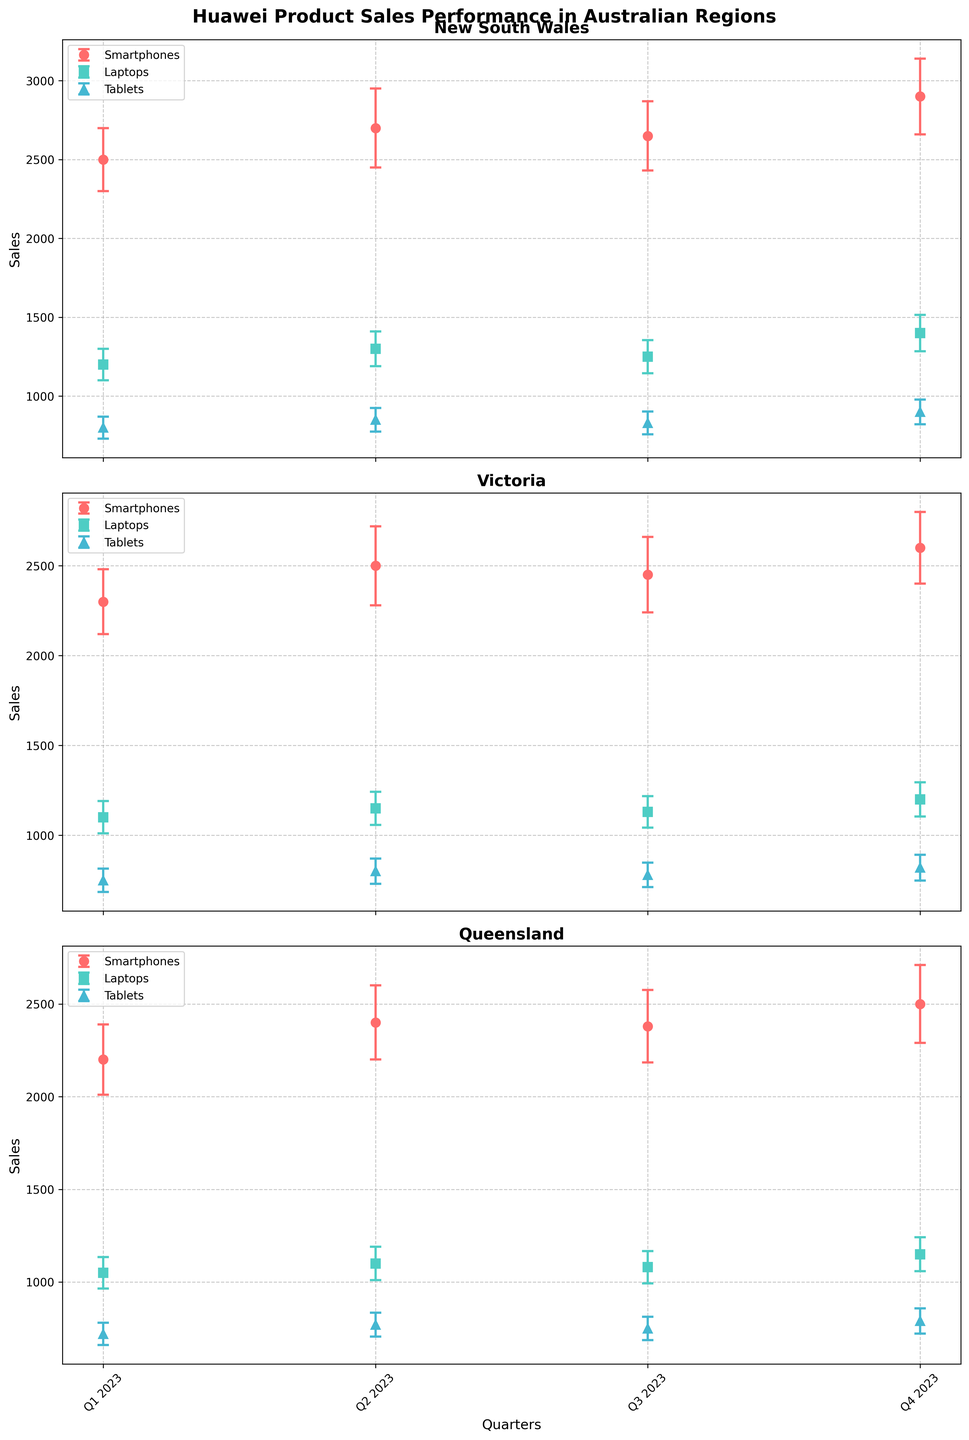What is the overall title of the figure? The overall title of the figure is displayed at the top and reads "Huawei Product Sales Performance in Australian Regions." One can directly see this from the figure's header.
Answer: Huawei Product Sales Performance in Australian Regions Which regions are represented in the subplots? The subplots are labeled according to the regions, which can be directly read from the titles of each subplot. These regions are "New South Wales," "Victoria," and "Queensland."
Answer: New South Wales, Victoria, Queensland How do the sales of Smartphones in New South Wales change from Q1 to Q4 2023? Reviewing the New South Wales subplot and the error bars for Smartphones, the sales figures in thousands are as follows: Q1: 2500, Q2: 2700, Q3: 2650, Q4: 2900. Thus, sales generally increase over the quarters.
Answer: They generally increase What is the highest variance in Tablet sales in Queensland? Looking at the error bars in the Queensland subplot for Tablets, the highest variance is in Q4 2023 at 68 units.
Answer: 68 Which product line has the least sales variance in Victoria throughout the year? Examining the error bars in the Victoria subplot across all product lines, Laptops exhibit the least variance throughout the quarters. This can be seen as the smallest error bars across all products.
Answer: Laptops Compare the average sales of Smartphones between New South Wales and Victoria. To find the average, sum the sales figures for each region and divide by four quarters. NSW: (2500 + 2700 + 2650 + 2900)/4 = 2687.5; Victoria: (2300 + 2500 + 2450 + 2600)/4 = 2462.5. NSW has higher average sales.
Answer: NSW: 2687.5, VIC: 2462.5 Which quarter shows the maximum sales for Laptops in New South Wales? In the New South Wales subplot, examining the data points for Laptops, Q4 2023 has the highest sales at 1400.
Answer: Q4 2023 Compare the trends of Tablet sales in Victoria and Queensland. Both subplots for Victoria and Queensland show the Tablet sales. In Victoria, there is a gradual increase from Q1 to Q4 2023. In Queensland, there is also an increase, but it's less pronounced.
Answer: Both increase; Victoria more pronounced Are there any quarters where the Laptop sales in New South Wales are equal to Laptop sales in Victoria? By examining both subplots for New South Wales and Victoria, we see that the Laptop sales are not equal in any quarter based on the provided data points.
Answer: No Which quarter shows the smallest variance in Smartphone sales in New South Wales? Looking at the error bars in the New South Wales subplot for Smartphones, Q1 2023 has the smallest variance at 200 units.
Answer: Q1 2023 